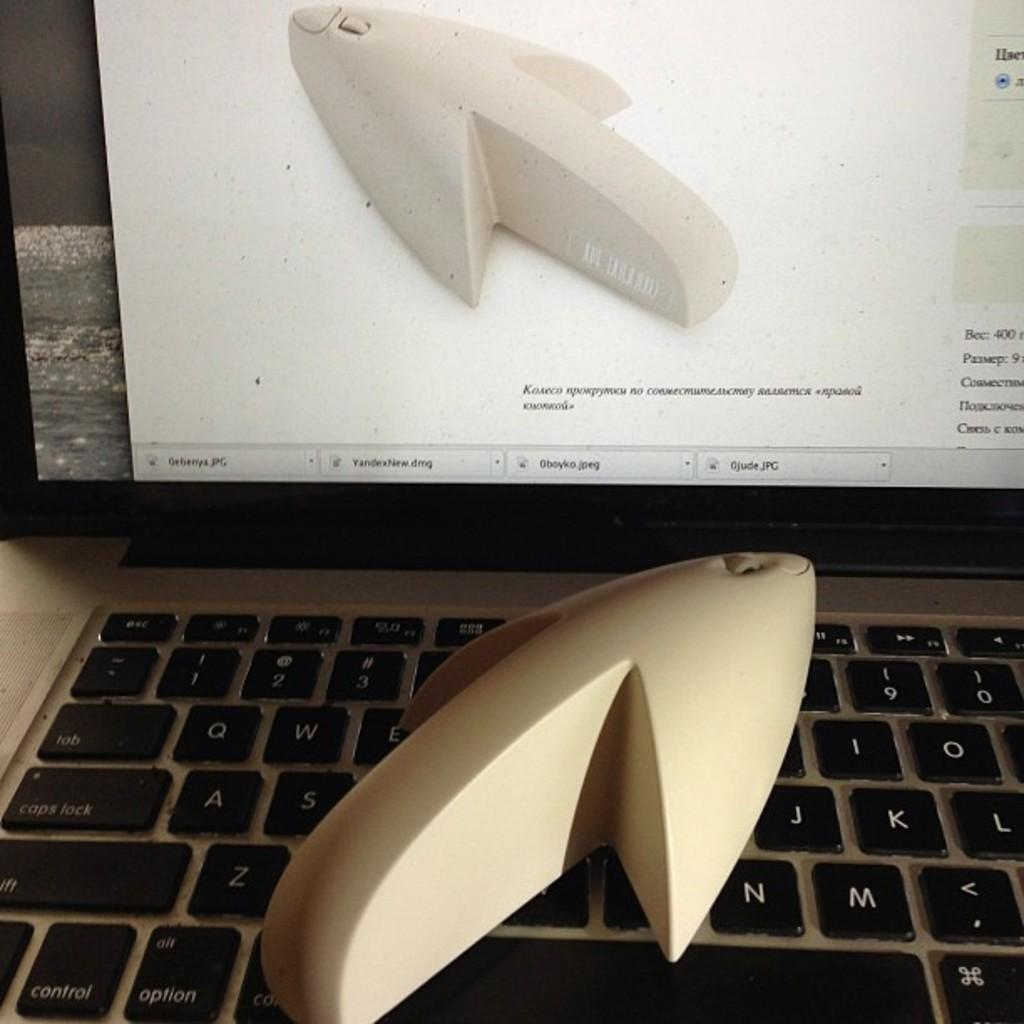<image>
Relay a brief, clear account of the picture shown. A white item displayed on the screen sits on the keyboard next to the option key. 